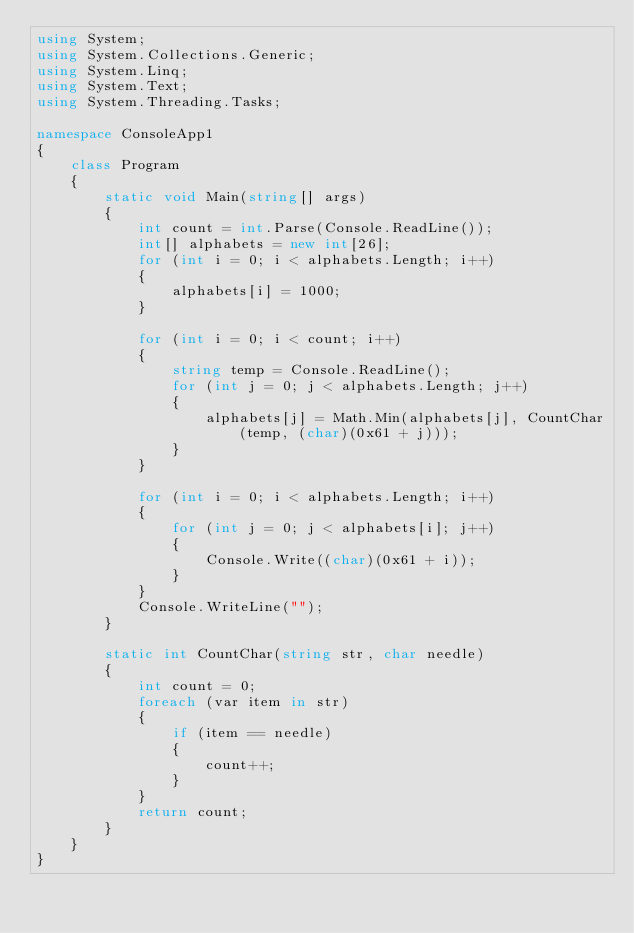Convert code to text. <code><loc_0><loc_0><loc_500><loc_500><_C#_>using System;
using System.Collections.Generic;
using System.Linq;
using System.Text;
using System.Threading.Tasks;

namespace ConsoleApp1
{
    class Program
    {
        static void Main(string[] args)
        {
            int count = int.Parse(Console.ReadLine());
            int[] alphabets = new int[26];
            for (int i = 0; i < alphabets.Length; i++)
            {
                alphabets[i] = 1000;
            }

            for (int i = 0; i < count; i++)
            {
                string temp = Console.ReadLine();
                for (int j = 0; j < alphabets.Length; j++)
                {
                    alphabets[j] = Math.Min(alphabets[j], CountChar(temp, (char)(0x61 + j)));
                }
            }

            for (int i = 0; i < alphabets.Length; i++)
            {
                for (int j = 0; j < alphabets[i]; j++)
                {
                    Console.Write((char)(0x61 + i));
                }
            }
            Console.WriteLine("");
        }

        static int CountChar(string str, char needle)
        {
            int count = 0;
            foreach (var item in str)
            {
                if (item == needle)
                {
                    count++;
                }
            }
            return count;
        }
    }
}
</code> 